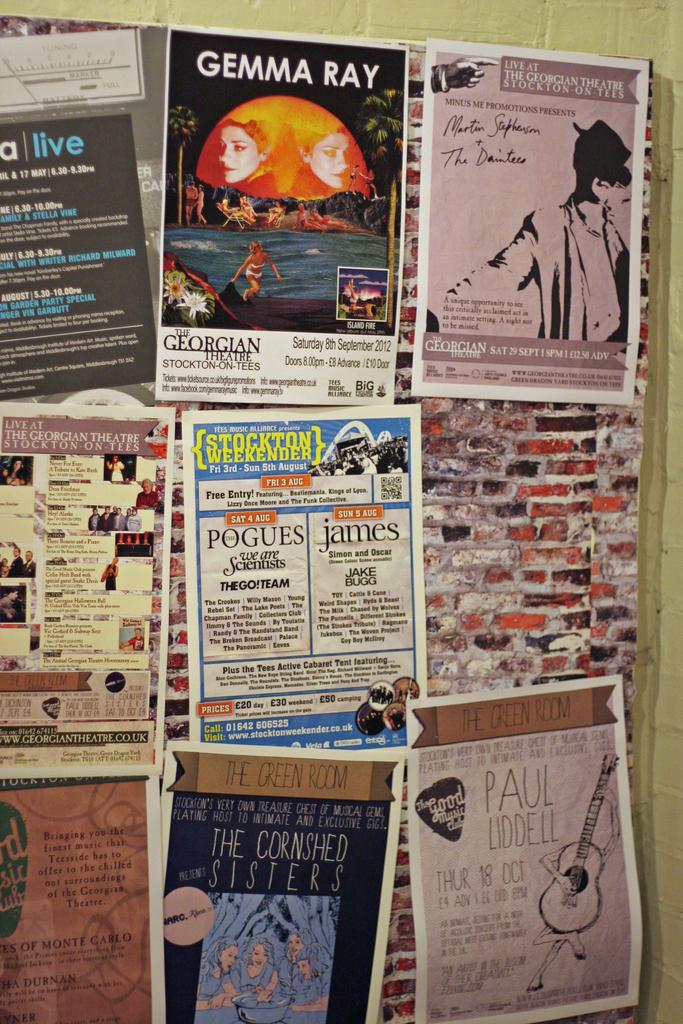Who is the author of the top-middle article?
Provide a succinct answer. Gemma ray. Who is advertised on the flyer on the bottom right?
Provide a short and direct response. Paul liddell. 